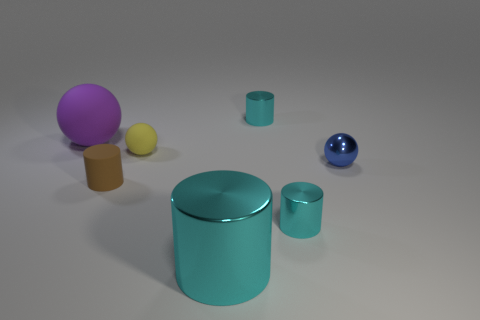Subtract all gray blocks. How many cyan cylinders are left? 3 Add 2 small green metal cylinders. How many objects exist? 9 Subtract all cylinders. How many objects are left? 3 Subtract 0 red blocks. How many objects are left? 7 Subtract all large yellow rubber cubes. Subtract all tiny cyan cylinders. How many objects are left? 5 Add 3 big cyan cylinders. How many big cyan cylinders are left? 4 Add 3 rubber spheres. How many rubber spheres exist? 5 